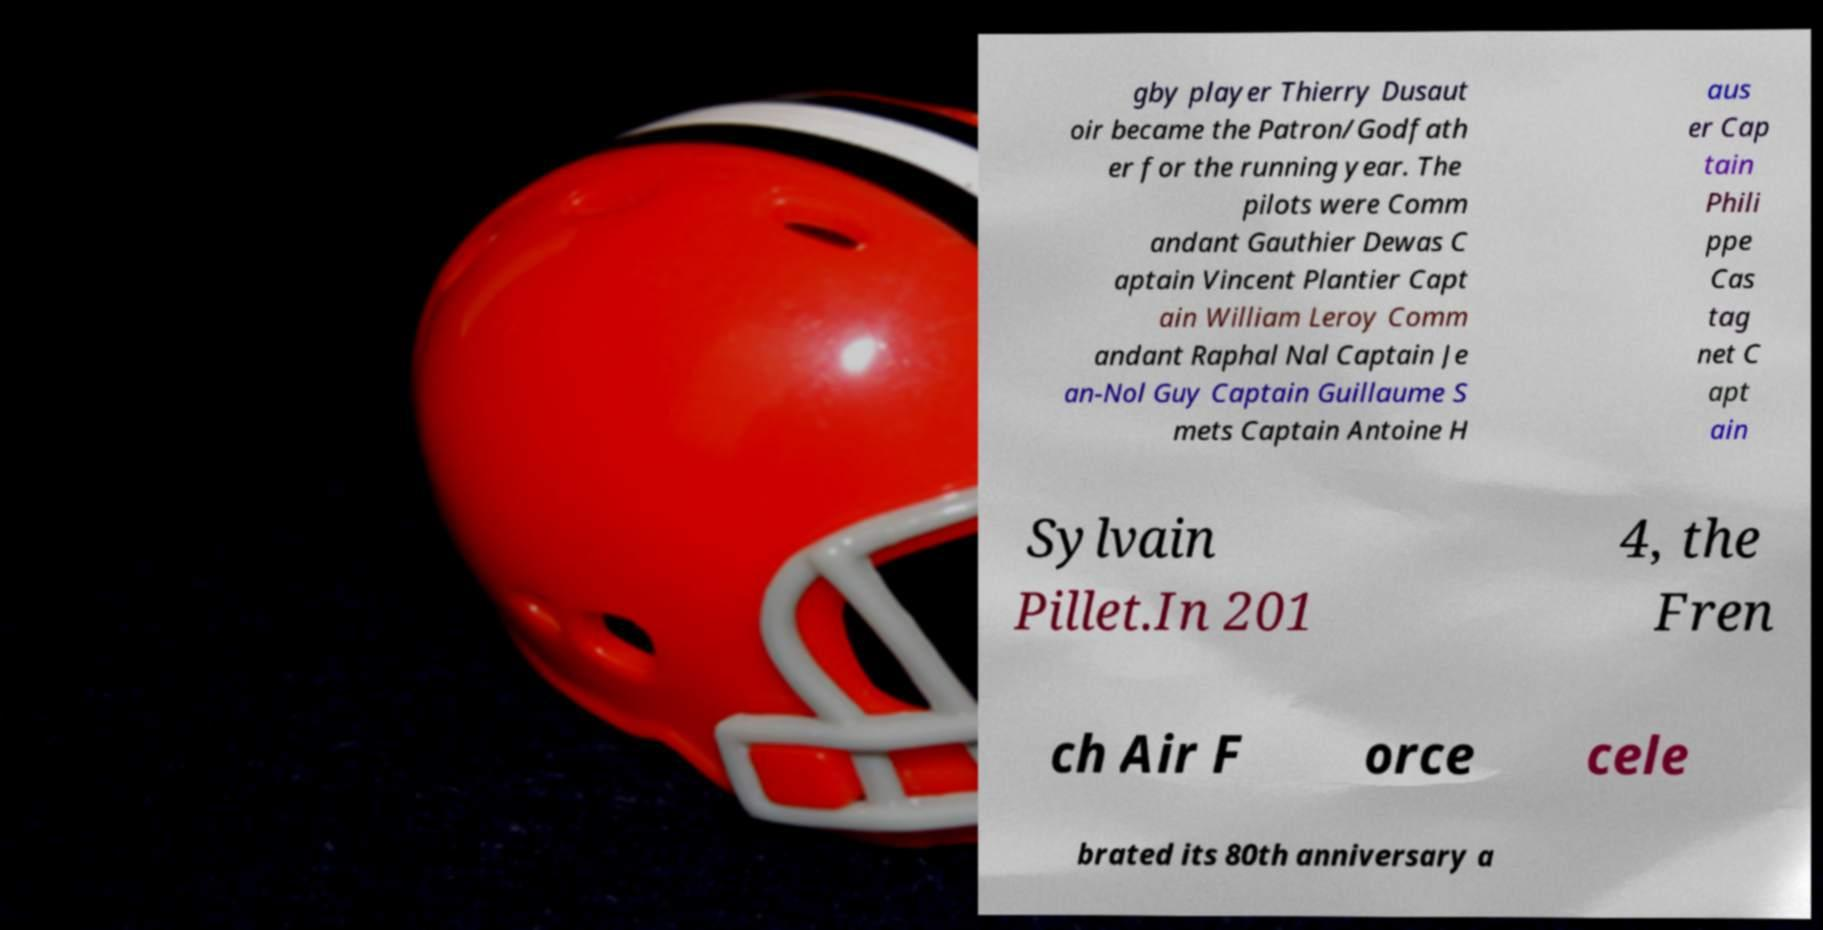I need the written content from this picture converted into text. Can you do that? gby player Thierry Dusaut oir became the Patron/Godfath er for the running year. The pilots were Comm andant Gauthier Dewas C aptain Vincent Plantier Capt ain William Leroy Comm andant Raphal Nal Captain Je an-Nol Guy Captain Guillaume S mets Captain Antoine H aus er Cap tain Phili ppe Cas tag net C apt ain Sylvain Pillet.In 201 4, the Fren ch Air F orce cele brated its 80th anniversary a 